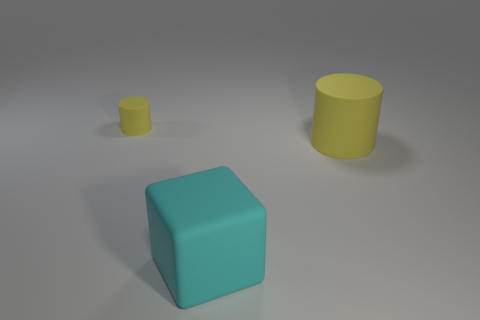Add 1 large rubber cubes. How many objects exist? 4 Subtract all blocks. How many objects are left? 2 Add 3 large rubber objects. How many large rubber objects are left? 5 Add 3 large yellow matte objects. How many large yellow matte objects exist? 4 Subtract 0 red blocks. How many objects are left? 3 Subtract all gray metallic things. Subtract all big cyan things. How many objects are left? 2 